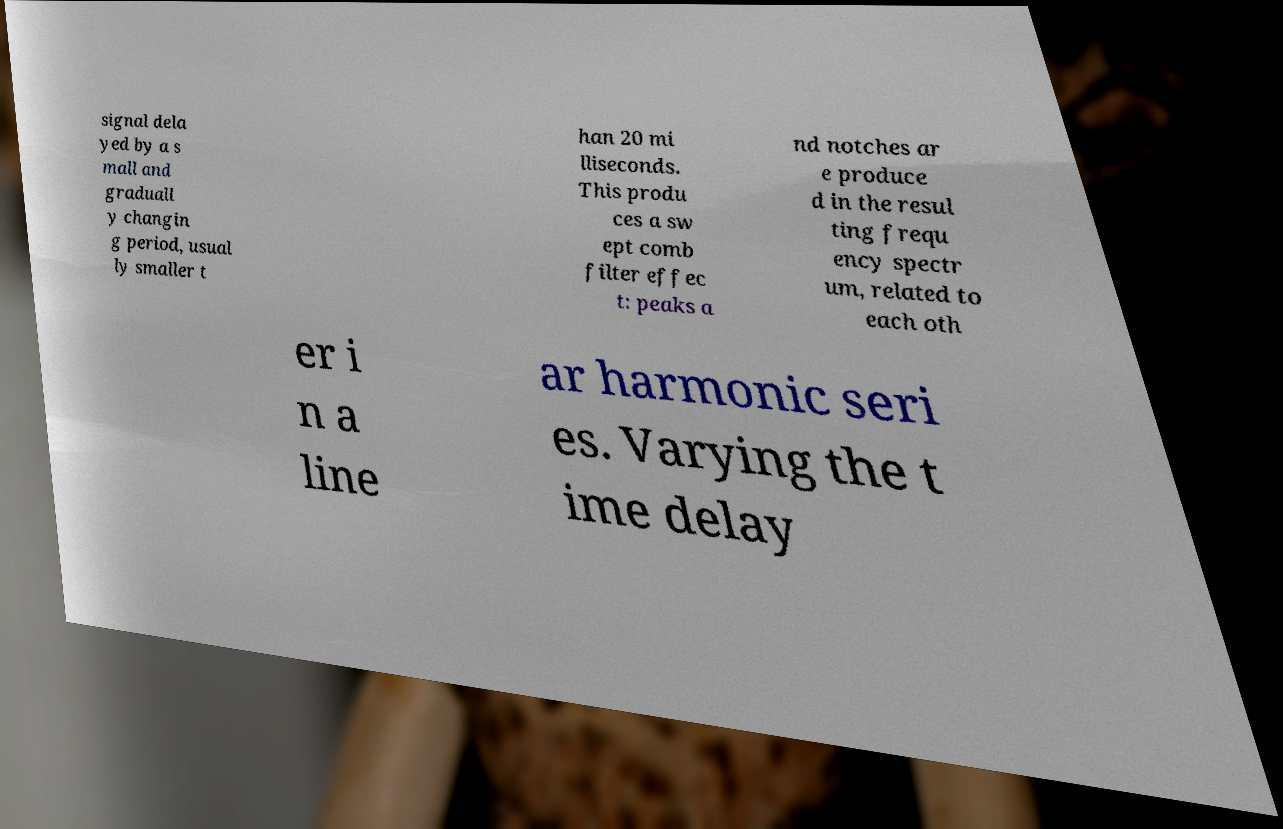Please identify and transcribe the text found in this image. signal dela yed by a s mall and graduall y changin g period, usual ly smaller t han 20 mi lliseconds. This produ ces a sw ept comb filter effec t: peaks a nd notches ar e produce d in the resul ting frequ ency spectr um, related to each oth er i n a line ar harmonic seri es. Varying the t ime delay 